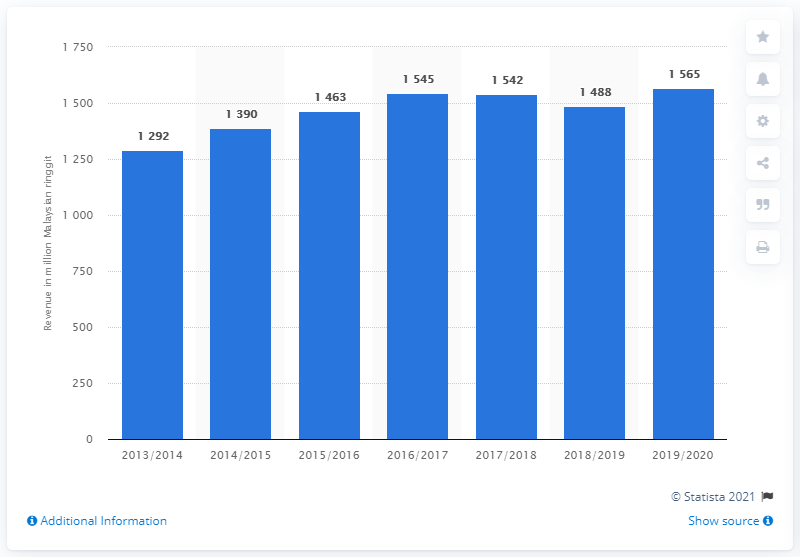List a handful of essential elements in this visual. In the 2019/20 fiscal year, MPI's revenue was 1565. 